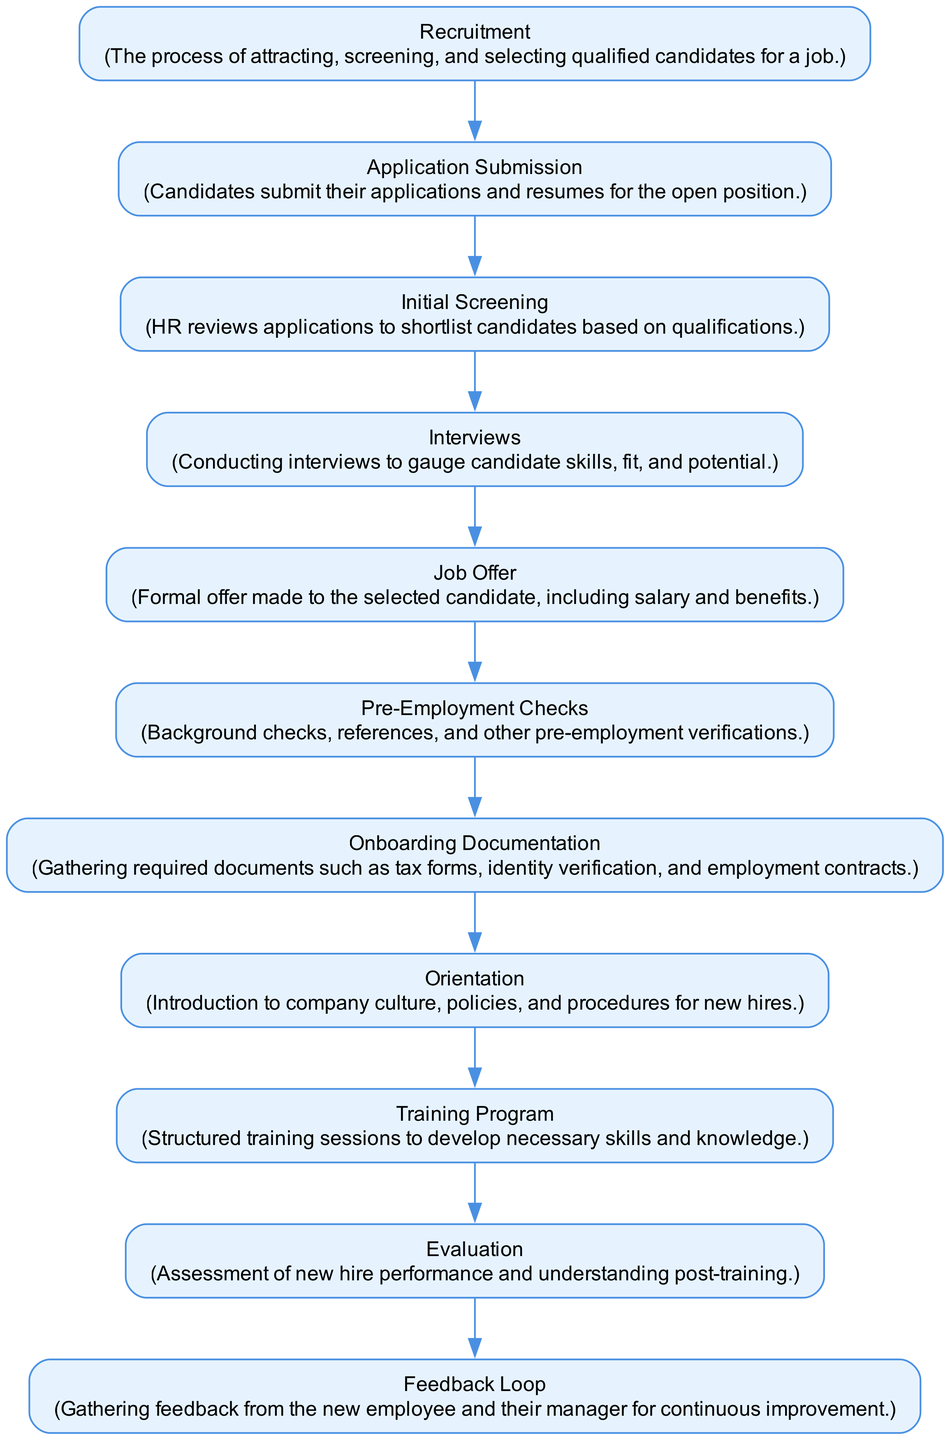What is the first step in the onboarding process? The diagram starts with the "Recruitment" node, which indicates that the onboarding process begins with attracting and selecting qualified candidates for a job.
Answer: Recruitment How many nodes are present in the diagram? By counting each unique node in the provided data, we can see there are a total of 11 nodes representing different steps in the onboarding process.
Answer: 11 What step comes after "Job Offer"? In the flow of the diagram, "Pre-Employment Checks" follows directly after the "Job Offer" node, indicating the next stage in the process.
Answer: Pre-Employment Checks What action follows "Training Program"? The "Evaluation" node is the next step after "Training Program," indicating that there is an assessment of the new hire's performance and understanding following the training.
Answer: Evaluation What documentation is required before orientation? "Onboarding Documentation" is necessary before the "Orientation" step, as it involves gathering required documents such as tax forms and employment contracts.
Answer: Onboarding Documentation How many edges are connected to the "Evaluation" node? Observing the diagram, the "Evaluation" node has only one outgoing edge connecting to the "Feedback Loop," which shows that this is the only path forward from that point.
Answer: 1 What is the purpose of the "Feedback Loop"? The "Feedback Loop" node is designed to gather feedback from the new employee and their manager for continuous improvement in the onboarding process.
Answer: Continuous improvement What is the relationship between "Interviews" and "Job Offer"? The edge from "Interviews" to "Job Offer" indicates that after the interview process is completed, a formal job offer is made to the selected candidate.
Answer: Job Offer Which step introduces new hires to company culture? The "Orientation" step is specifically aimed at introducing new employees to the company culture, policies, and procedures.
Answer: Orientation 